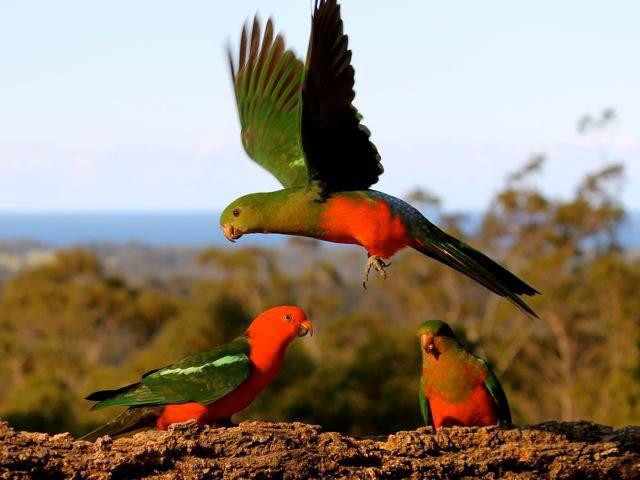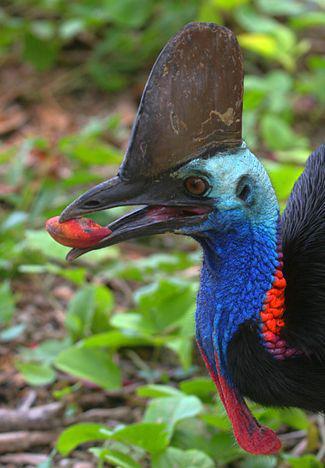The first image is the image on the left, the second image is the image on the right. For the images shown, is this caption "Two birds share a branch in the image on the right." true? Answer yes or no. No. 